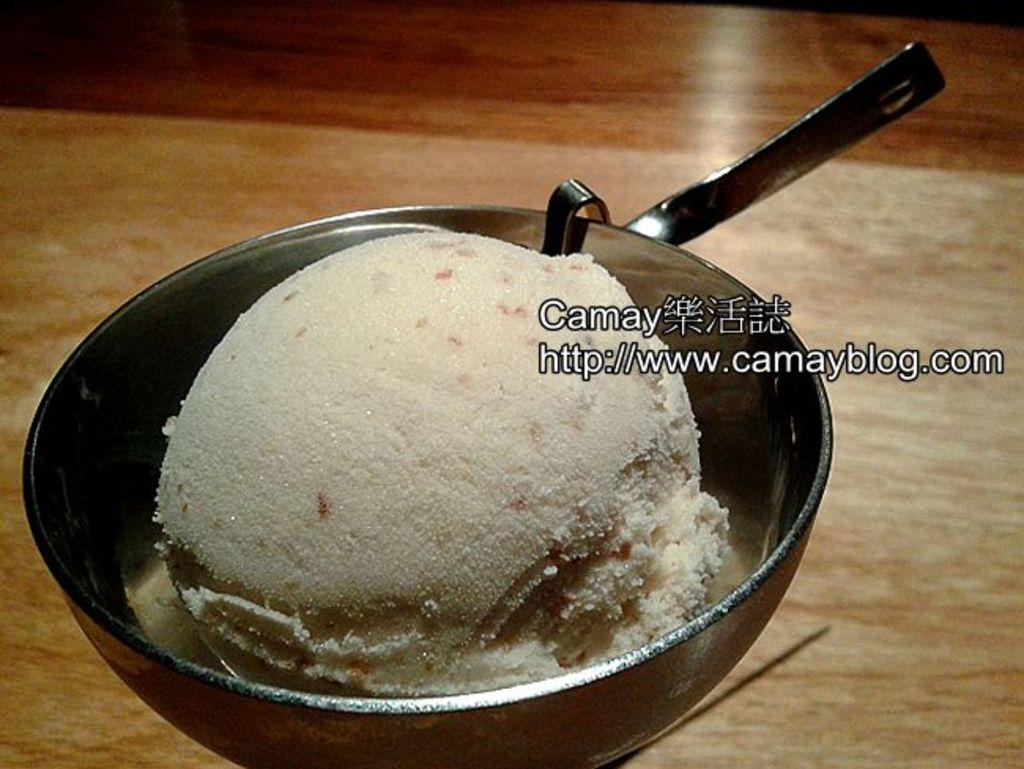What is placed in a bowl in the image? There is an edible placed in a bowl in the image. Can you describe what is written beside the edible? Unfortunately, the facts provided do not give any information about what is written beside the edible. What type of wood is used to create the invention in the image? There is no mention of an invention or wood in the image, so it is not possible to answer that question. 